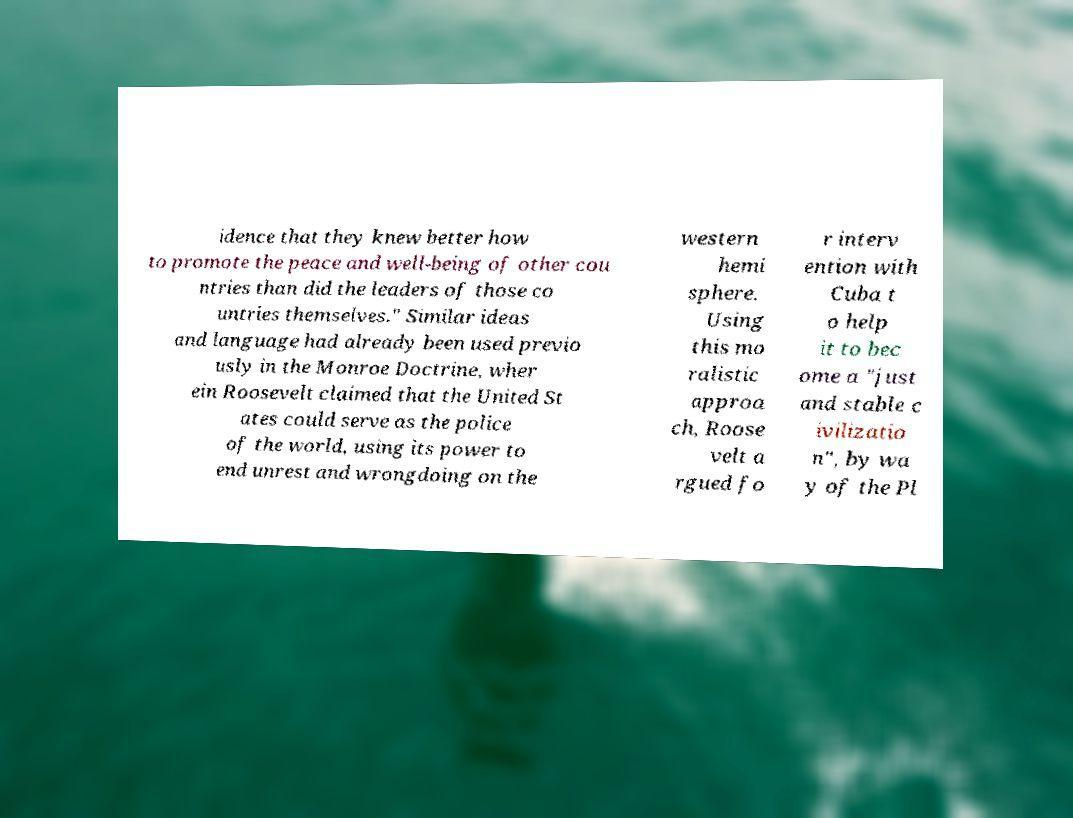There's text embedded in this image that I need extracted. Can you transcribe it verbatim? idence that they knew better how to promote the peace and well-being of other cou ntries than did the leaders of those co untries themselves." Similar ideas and language had already been used previo usly in the Monroe Doctrine, wher ein Roosevelt claimed that the United St ates could serve as the police of the world, using its power to end unrest and wrongdoing on the western hemi sphere. Using this mo ralistic approa ch, Roose velt a rgued fo r interv ention with Cuba t o help it to bec ome a "just and stable c ivilizatio n", by wa y of the Pl 